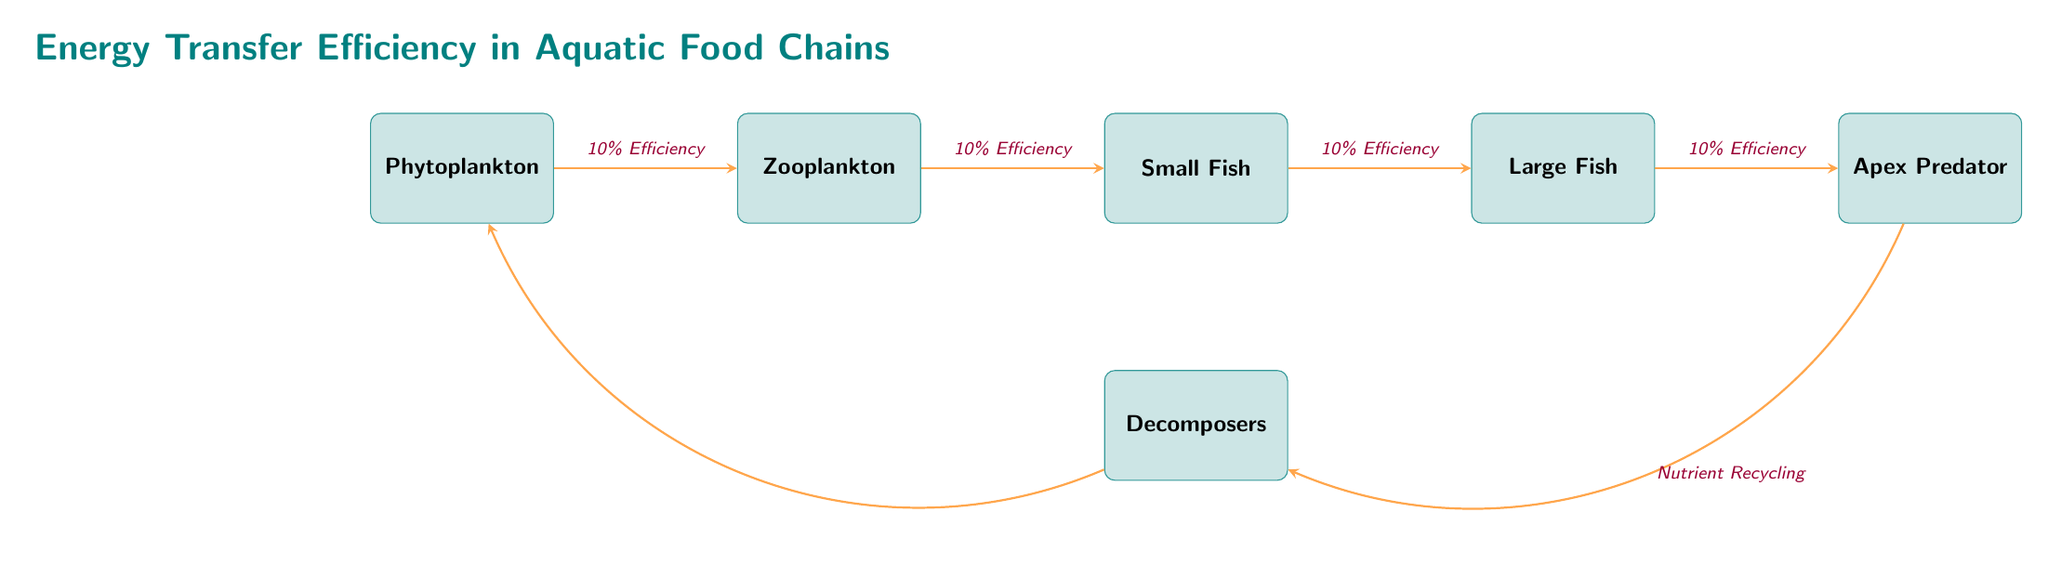What is the first organism in the food chain? The diagram shows Phytoplankton as the first organism, positioned at the far left of the sequence.
Answer: Phytoplankton How many nodes are present in the food chain? The diagram includes five main organisms (Phytoplankton, Zooplankton, Small Fish, Large Fish, and Apex Predator) plus Decomposers below, totaling six nodes.
Answer: 6 What is the efficiency of energy transfer from Zooplankton to Small Fish? The arrow connecting Zooplankton to Small Fish indicates an energy transfer efficiency of 10%.
Answer: 10% What type of organism is located beneath Small Fish? The diagram shows Decomposers directly below the Small Fish node, indicating its classification.
Answer: Decomposers Which organism has the highest trophic level in the food chain? Apex Predator is the final node in the sequence, representing the highest trophic level in the food chain structure.
Answer: Apex Predator What happens to nutrients after they pass through the Apex Predator? The diagram illustrates that nutrients are recycled back to the Decomposers after passing through the Apex Predator.
Answer: Nutrient Recycling What is the overall efficiency of energy transfer from Phytoplankton to Apex Predator? Starting with 10% efficiency through each of the four energy transfer stages will multiply, so the overall efficiency is 10% * 10% * 10% * 10% = 0.1%, the result of the compounding losses throughout the chain.
Answer: 0.1% What is the relationship between Decomposers and Phytoplankton in the diagram? The diagram indicates a cycle where Decomposers contribute nutrients back to Phytoplankton, thus showing a nutrient recycling system between them.
Answer: Nutrient Recycling How many arrows indicate energy transfer in the diagram? There are a total of four arrows that depict energy transfers between the five organisms in the food chain.
Answer: 4 